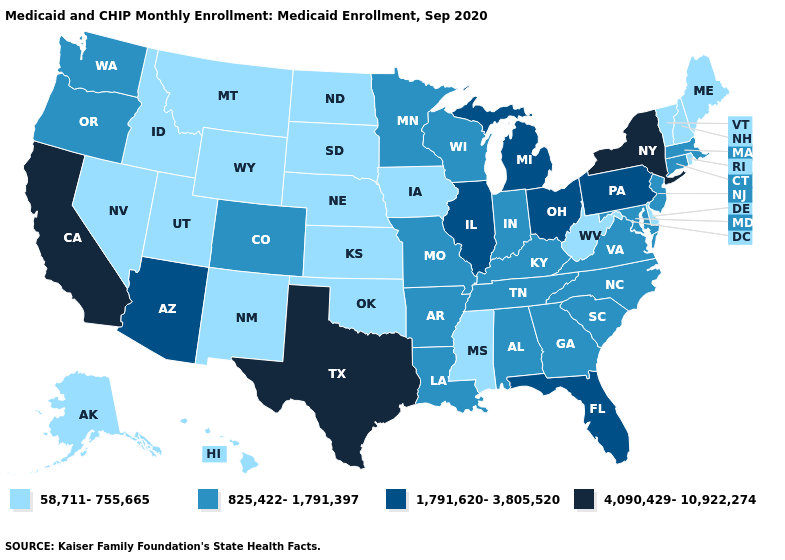Name the states that have a value in the range 1,791,620-3,805,520?
Short answer required. Arizona, Florida, Illinois, Michigan, Ohio, Pennsylvania. Does Mississippi have the highest value in the South?
Short answer required. No. What is the value of Minnesota?
Write a very short answer. 825,422-1,791,397. Name the states that have a value in the range 58,711-755,665?
Give a very brief answer. Alaska, Delaware, Hawaii, Idaho, Iowa, Kansas, Maine, Mississippi, Montana, Nebraska, Nevada, New Hampshire, New Mexico, North Dakota, Oklahoma, Rhode Island, South Dakota, Utah, Vermont, West Virginia, Wyoming. Name the states that have a value in the range 4,090,429-10,922,274?
Answer briefly. California, New York, Texas. Which states have the lowest value in the South?
Answer briefly. Delaware, Mississippi, Oklahoma, West Virginia. Does Louisiana have the lowest value in the USA?
Be succinct. No. Does the first symbol in the legend represent the smallest category?
Concise answer only. Yes. Which states have the lowest value in the South?
Answer briefly. Delaware, Mississippi, Oklahoma, West Virginia. What is the highest value in states that border Nevada?
Short answer required. 4,090,429-10,922,274. Among the states that border Rhode Island , which have the lowest value?
Write a very short answer. Connecticut, Massachusetts. What is the highest value in states that border Mississippi?
Give a very brief answer. 825,422-1,791,397. How many symbols are there in the legend?
Concise answer only. 4. Does Vermont have a lower value than Indiana?
Be succinct. Yes. Which states have the lowest value in the USA?
Quick response, please. Alaska, Delaware, Hawaii, Idaho, Iowa, Kansas, Maine, Mississippi, Montana, Nebraska, Nevada, New Hampshire, New Mexico, North Dakota, Oklahoma, Rhode Island, South Dakota, Utah, Vermont, West Virginia, Wyoming. 